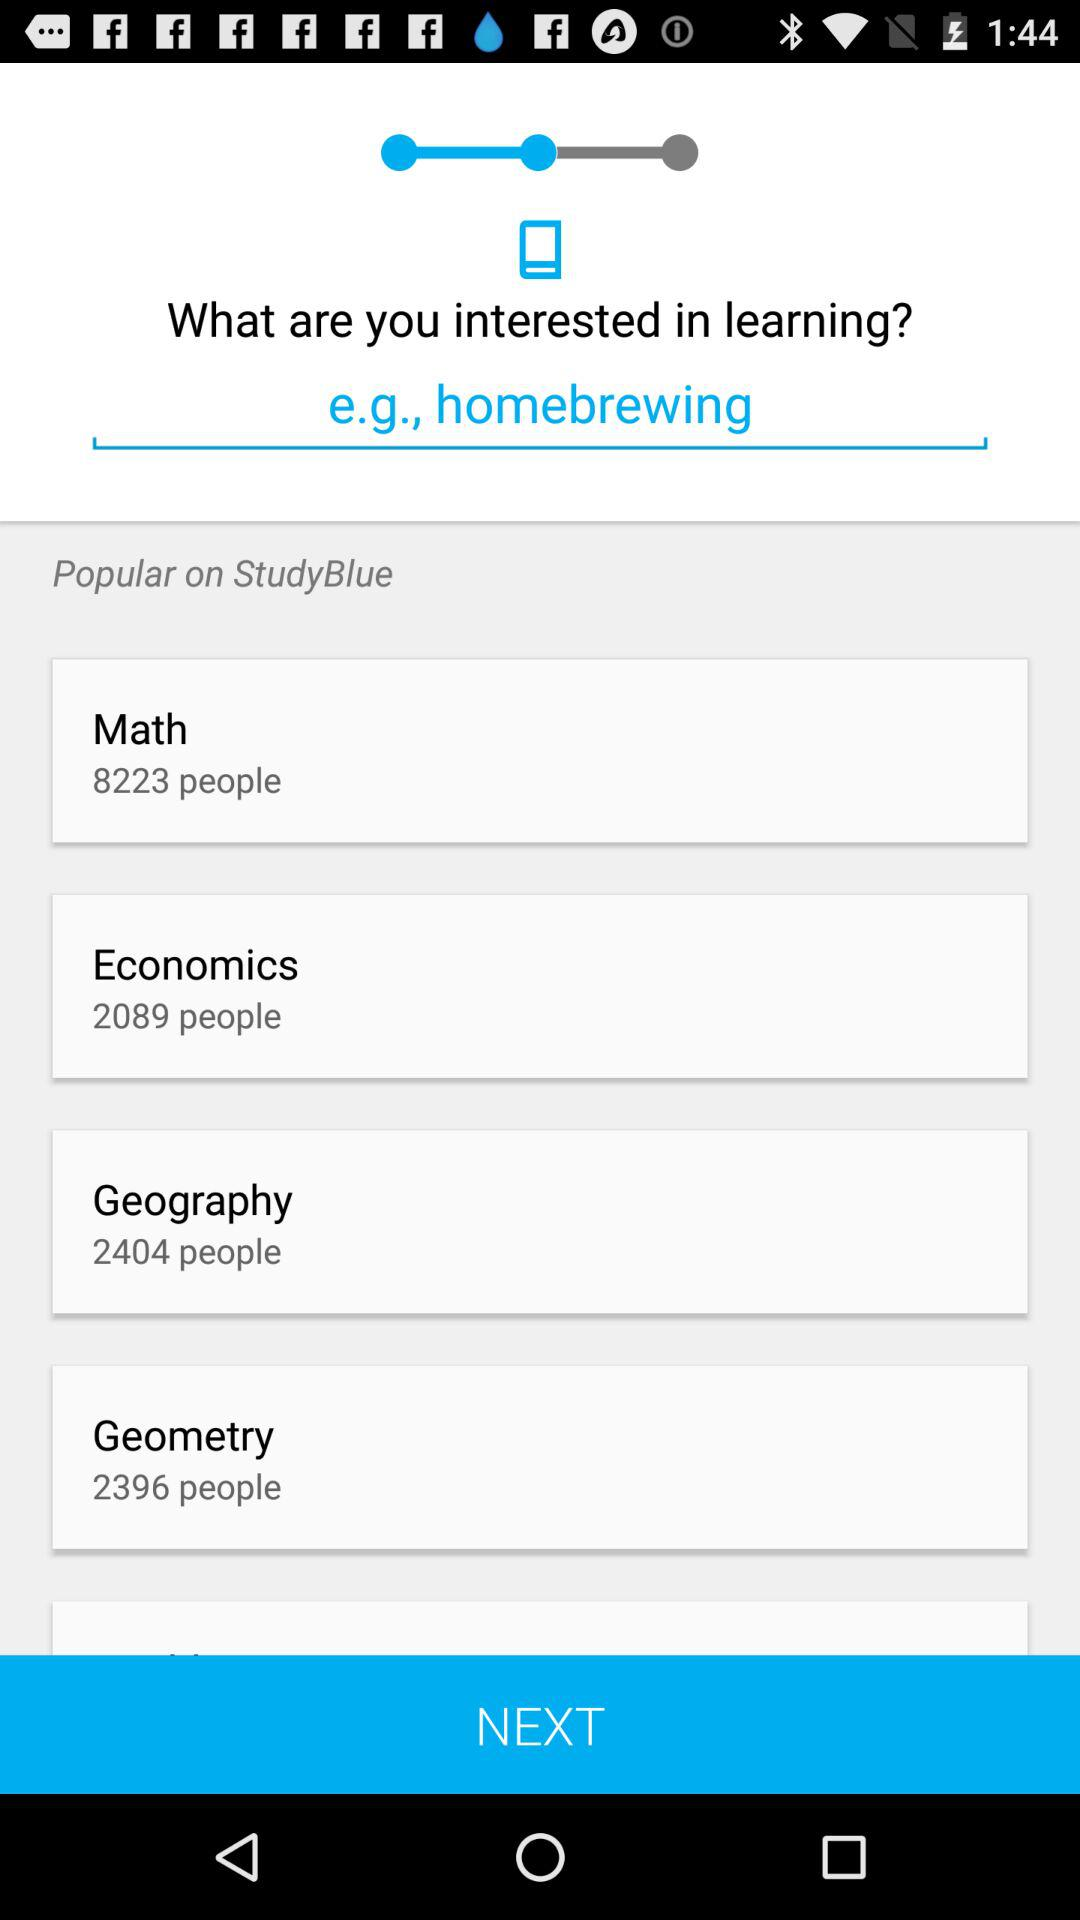How many people in total are there in geography? There are 2404 people in geography. 